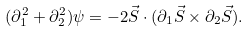<formula> <loc_0><loc_0><loc_500><loc_500>( \partial _ { 1 } ^ { 2 } + \partial _ { 2 } ^ { 2 } ) \psi = - 2 \vec { S } \cdot ( \partial _ { 1 } \vec { S } \times \partial _ { 2 } \vec { S } ) .</formula> 